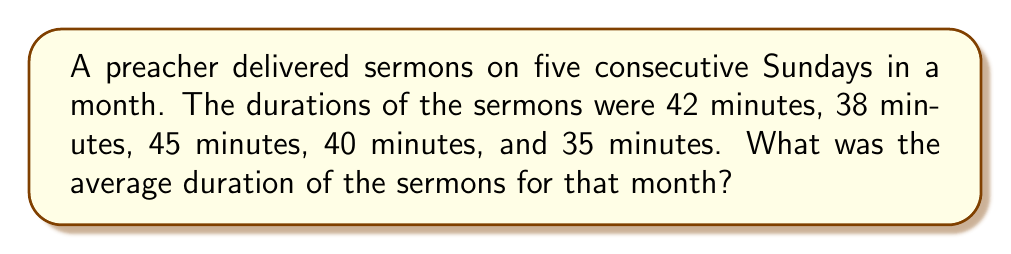Give your solution to this math problem. To find the average duration of the sermons, we need to follow these steps:

1. Add up the durations of all sermons:
   $42 + 38 + 45 + 40 + 35 = 200$ minutes

2. Count the total number of sermons:
   There were 5 sermons in total.

3. Calculate the average by dividing the total duration by the number of sermons:
   $$\text{Average} = \frac{\text{Total duration}}{\text{Number of sermons}} = \frac{200}{5} = 40$$

Therefore, the average duration of the sermons for that month was 40 minutes.
Answer: 40 minutes 